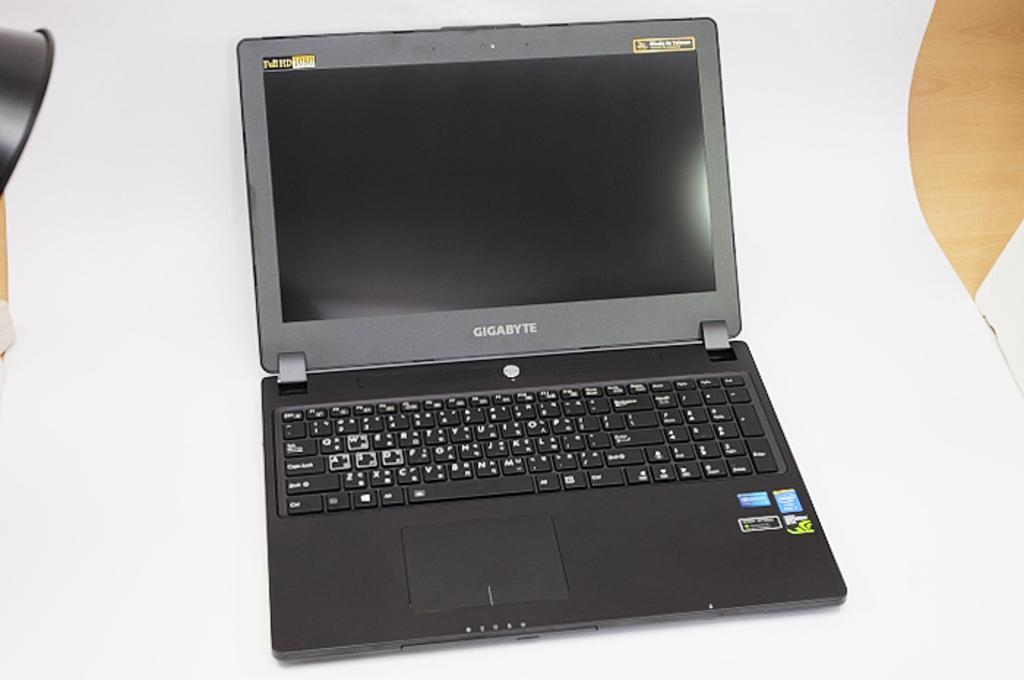Provide a one-sentence caption for the provided image. a grey lap top computer with the words Gigabyte on it. 